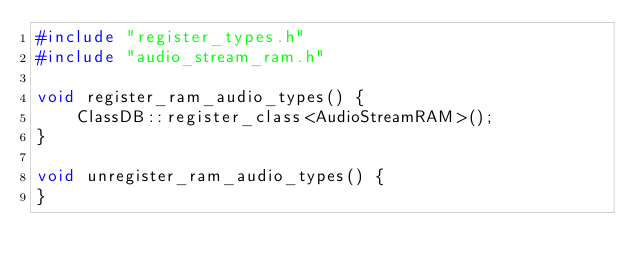<code> <loc_0><loc_0><loc_500><loc_500><_C++_>#include "register_types.h"
#include "audio_stream_ram.h"

void register_ram_audio_types() {
	ClassDB::register_class<AudioStreamRAM>();
}

void unregister_ram_audio_types() {
}
</code> 